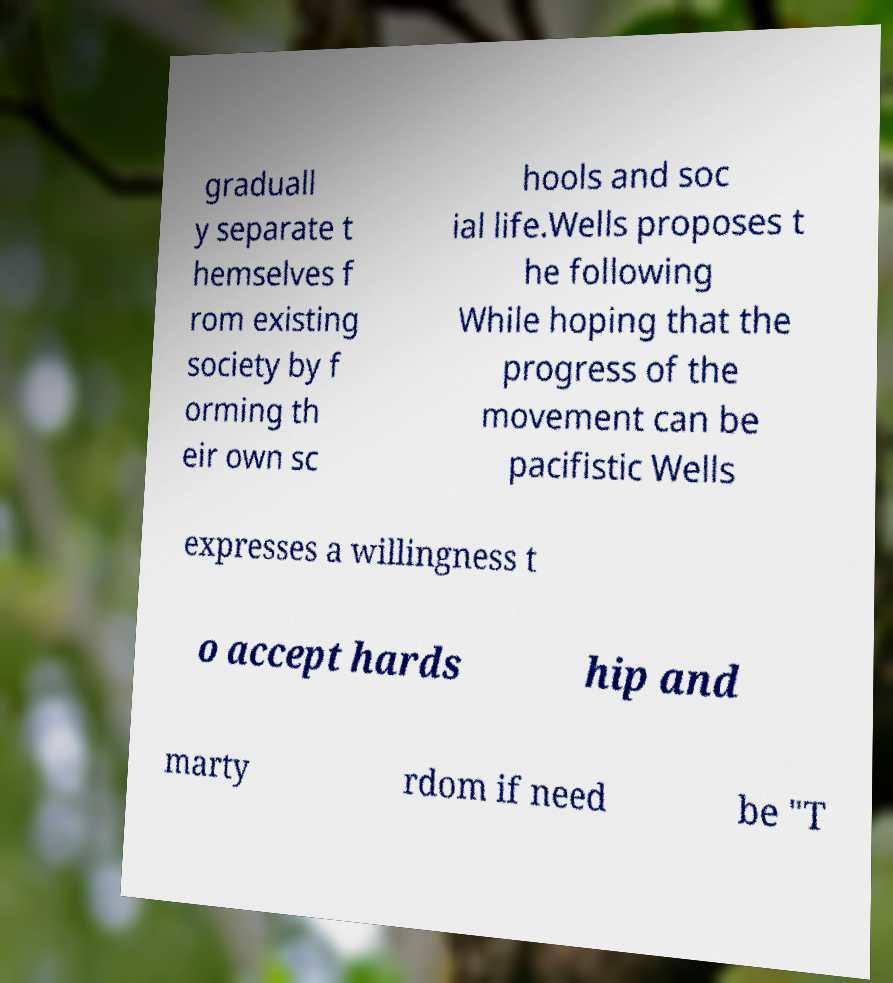Can you accurately transcribe the text from the provided image for me? graduall y separate t hemselves f rom existing society by f orming th eir own sc hools and soc ial life.Wells proposes t he following While hoping that the progress of the movement can be pacifistic Wells expresses a willingness t o accept hards hip and marty rdom if need be "T 